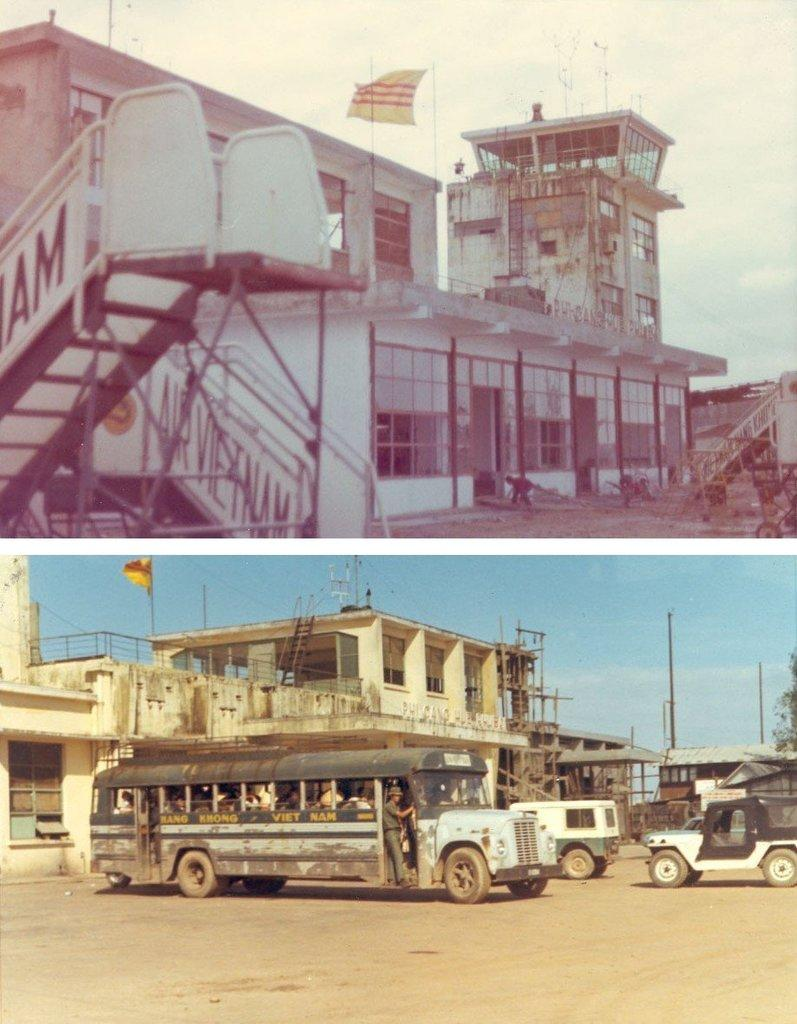What type of structures can be seen in the image? There are buildings in the image. What architectural features are visible on the buildings? There are windows visible on the buildings. What type of transportation is present in the image? There are vehicles in the image. What other objects can be seen in the image? There are poles, trees, a ladder, and a flag in the image. What is the color of the sky in the image? The sky is blue and white in color. How is the image composed? It is a collage image. How many apples are hanging from the trees in the image? There are no apples present in the image; it only features trees. How many girls are visible in the image? There are no girls present in the image; it is a collage of buildings, vehicles, poles, trees, a ladder, and a flag. 